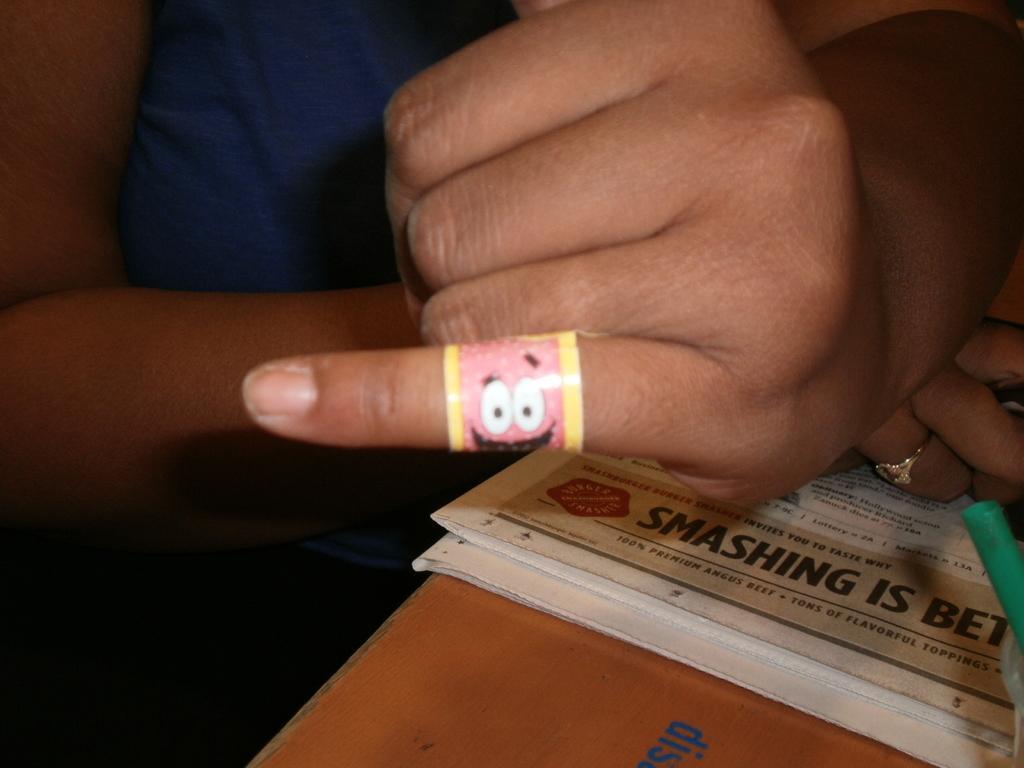Describe this image in one or two sentences. In this picture we can see the woman hands and fingers. On the bottom side there is a newspaper. Behind there is a blur background. 